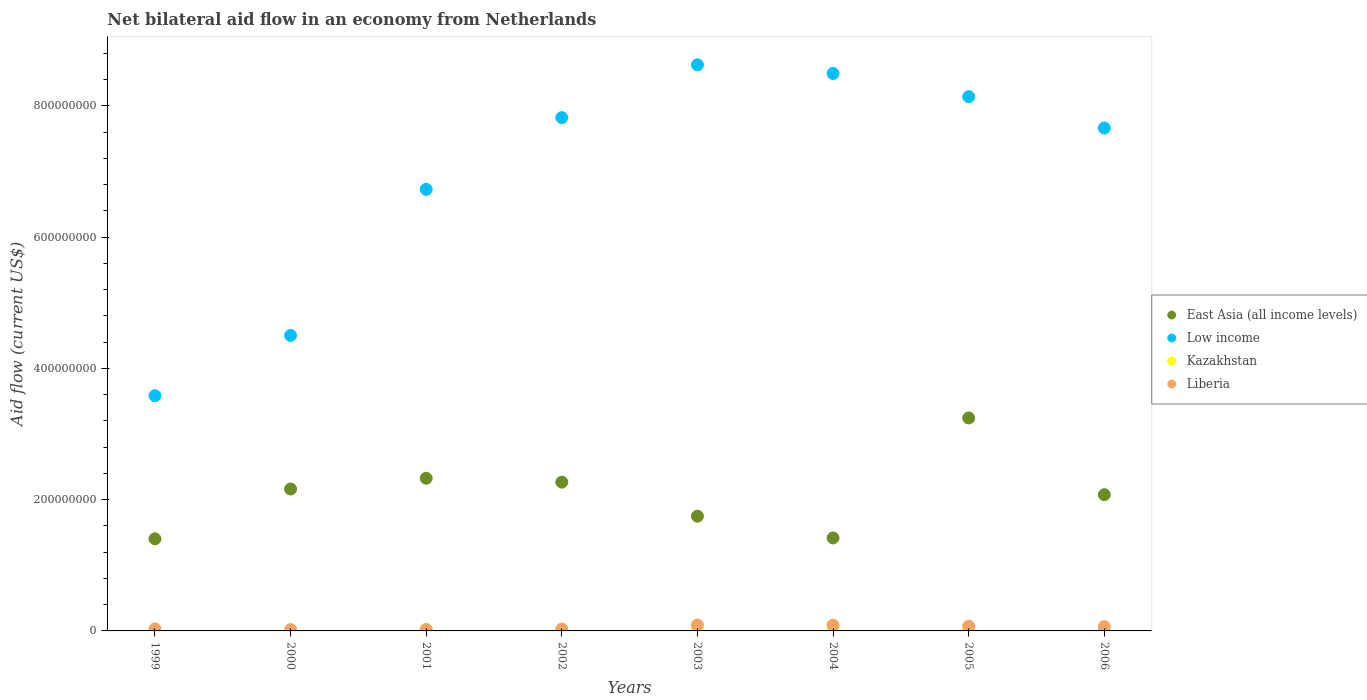How many different coloured dotlines are there?
Your response must be concise. 4. What is the net bilateral aid flow in Liberia in 2002?
Your response must be concise. 2.88e+06. Across all years, what is the maximum net bilateral aid flow in Low income?
Offer a very short reply. 8.63e+08. Across all years, what is the minimum net bilateral aid flow in East Asia (all income levels)?
Provide a succinct answer. 1.40e+08. In which year was the net bilateral aid flow in East Asia (all income levels) maximum?
Give a very brief answer. 2005. In which year was the net bilateral aid flow in East Asia (all income levels) minimum?
Your answer should be compact. 1999. What is the total net bilateral aid flow in Kazakhstan in the graph?
Keep it short and to the point. 1.30e+07. What is the difference between the net bilateral aid flow in East Asia (all income levels) in 1999 and that in 2000?
Give a very brief answer. -7.59e+07. What is the difference between the net bilateral aid flow in East Asia (all income levels) in 1999 and the net bilateral aid flow in Low income in 2001?
Your answer should be very brief. -5.33e+08. What is the average net bilateral aid flow in East Asia (all income levels) per year?
Give a very brief answer. 2.08e+08. In the year 2006, what is the difference between the net bilateral aid flow in Liberia and net bilateral aid flow in East Asia (all income levels)?
Your response must be concise. -2.01e+08. What is the ratio of the net bilateral aid flow in Low income in 1999 to that in 2004?
Keep it short and to the point. 0.42. Is the difference between the net bilateral aid flow in Liberia in 2001 and 2002 greater than the difference between the net bilateral aid flow in East Asia (all income levels) in 2001 and 2002?
Provide a short and direct response. No. What is the difference between the highest and the lowest net bilateral aid flow in Liberia?
Provide a short and direct response. 6.98e+06. In how many years, is the net bilateral aid flow in Low income greater than the average net bilateral aid flow in Low income taken over all years?
Provide a succinct answer. 5. How many dotlines are there?
Make the answer very short. 4. Does the graph contain grids?
Provide a succinct answer. No. Where does the legend appear in the graph?
Keep it short and to the point. Center right. How many legend labels are there?
Your answer should be very brief. 4. What is the title of the graph?
Your answer should be compact. Net bilateral aid flow in an economy from Netherlands. What is the label or title of the X-axis?
Provide a short and direct response. Years. What is the label or title of the Y-axis?
Keep it short and to the point. Aid flow (current US$). What is the Aid flow (current US$) in East Asia (all income levels) in 1999?
Ensure brevity in your answer.  1.40e+08. What is the Aid flow (current US$) of Low income in 1999?
Your answer should be very brief. 3.58e+08. What is the Aid flow (current US$) in Kazakhstan in 1999?
Your response must be concise. 1.20e+05. What is the Aid flow (current US$) of Liberia in 1999?
Make the answer very short. 3.16e+06. What is the Aid flow (current US$) in East Asia (all income levels) in 2000?
Your answer should be compact. 2.16e+08. What is the Aid flow (current US$) in Low income in 2000?
Give a very brief answer. 4.50e+08. What is the Aid flow (current US$) of Kazakhstan in 2000?
Offer a very short reply. 2.90e+05. What is the Aid flow (current US$) in East Asia (all income levels) in 2001?
Offer a terse response. 2.33e+08. What is the Aid flow (current US$) of Low income in 2001?
Offer a very short reply. 6.73e+08. What is the Aid flow (current US$) in Kazakhstan in 2001?
Keep it short and to the point. 2.15e+06. What is the Aid flow (current US$) of Liberia in 2001?
Your answer should be very brief. 2.25e+06. What is the Aid flow (current US$) of East Asia (all income levels) in 2002?
Make the answer very short. 2.27e+08. What is the Aid flow (current US$) in Low income in 2002?
Make the answer very short. 7.82e+08. What is the Aid flow (current US$) of Kazakhstan in 2002?
Make the answer very short. 2.01e+06. What is the Aid flow (current US$) in Liberia in 2002?
Keep it short and to the point. 2.88e+06. What is the Aid flow (current US$) of East Asia (all income levels) in 2003?
Provide a short and direct response. 1.75e+08. What is the Aid flow (current US$) in Low income in 2003?
Offer a terse response. 8.63e+08. What is the Aid flow (current US$) in Kazakhstan in 2003?
Your answer should be very brief. 2.51e+06. What is the Aid flow (current US$) in Liberia in 2003?
Your response must be concise. 8.98e+06. What is the Aid flow (current US$) of East Asia (all income levels) in 2004?
Your answer should be very brief. 1.42e+08. What is the Aid flow (current US$) in Low income in 2004?
Give a very brief answer. 8.49e+08. What is the Aid flow (current US$) of Kazakhstan in 2004?
Your answer should be very brief. 3.32e+06. What is the Aid flow (current US$) in Liberia in 2004?
Keep it short and to the point. 8.62e+06. What is the Aid flow (current US$) in East Asia (all income levels) in 2005?
Offer a terse response. 3.25e+08. What is the Aid flow (current US$) in Low income in 2005?
Offer a very short reply. 8.14e+08. What is the Aid flow (current US$) in Kazakhstan in 2005?
Your answer should be compact. 2.36e+06. What is the Aid flow (current US$) in Liberia in 2005?
Provide a succinct answer. 7.20e+06. What is the Aid flow (current US$) of East Asia (all income levels) in 2006?
Provide a succinct answer. 2.08e+08. What is the Aid flow (current US$) of Low income in 2006?
Keep it short and to the point. 7.66e+08. What is the Aid flow (current US$) of Liberia in 2006?
Your answer should be very brief. 6.53e+06. Across all years, what is the maximum Aid flow (current US$) of East Asia (all income levels)?
Ensure brevity in your answer.  3.25e+08. Across all years, what is the maximum Aid flow (current US$) of Low income?
Your answer should be very brief. 8.63e+08. Across all years, what is the maximum Aid flow (current US$) in Kazakhstan?
Your response must be concise. 3.32e+06. Across all years, what is the maximum Aid flow (current US$) in Liberia?
Make the answer very short. 8.98e+06. Across all years, what is the minimum Aid flow (current US$) of East Asia (all income levels)?
Keep it short and to the point. 1.40e+08. Across all years, what is the minimum Aid flow (current US$) of Low income?
Keep it short and to the point. 3.58e+08. What is the total Aid flow (current US$) of East Asia (all income levels) in the graph?
Your answer should be very brief. 1.66e+09. What is the total Aid flow (current US$) of Low income in the graph?
Provide a succinct answer. 5.56e+09. What is the total Aid flow (current US$) of Kazakhstan in the graph?
Ensure brevity in your answer.  1.30e+07. What is the total Aid flow (current US$) in Liberia in the graph?
Provide a short and direct response. 4.16e+07. What is the difference between the Aid flow (current US$) of East Asia (all income levels) in 1999 and that in 2000?
Your answer should be compact. -7.59e+07. What is the difference between the Aid flow (current US$) of Low income in 1999 and that in 2000?
Offer a very short reply. -9.18e+07. What is the difference between the Aid flow (current US$) in Liberia in 1999 and that in 2000?
Your response must be concise. 1.16e+06. What is the difference between the Aid flow (current US$) in East Asia (all income levels) in 1999 and that in 2001?
Ensure brevity in your answer.  -9.23e+07. What is the difference between the Aid flow (current US$) in Low income in 1999 and that in 2001?
Make the answer very short. -3.14e+08. What is the difference between the Aid flow (current US$) in Kazakhstan in 1999 and that in 2001?
Provide a succinct answer. -2.03e+06. What is the difference between the Aid flow (current US$) in Liberia in 1999 and that in 2001?
Make the answer very short. 9.10e+05. What is the difference between the Aid flow (current US$) in East Asia (all income levels) in 1999 and that in 2002?
Offer a very short reply. -8.64e+07. What is the difference between the Aid flow (current US$) of Low income in 1999 and that in 2002?
Your answer should be compact. -4.24e+08. What is the difference between the Aid flow (current US$) of Kazakhstan in 1999 and that in 2002?
Give a very brief answer. -1.89e+06. What is the difference between the Aid flow (current US$) in Liberia in 1999 and that in 2002?
Keep it short and to the point. 2.80e+05. What is the difference between the Aid flow (current US$) of East Asia (all income levels) in 1999 and that in 2003?
Ensure brevity in your answer.  -3.45e+07. What is the difference between the Aid flow (current US$) of Low income in 1999 and that in 2003?
Your answer should be compact. -5.04e+08. What is the difference between the Aid flow (current US$) in Kazakhstan in 1999 and that in 2003?
Offer a terse response. -2.39e+06. What is the difference between the Aid flow (current US$) of Liberia in 1999 and that in 2003?
Your answer should be very brief. -5.82e+06. What is the difference between the Aid flow (current US$) of East Asia (all income levels) in 1999 and that in 2004?
Make the answer very short. -1.30e+06. What is the difference between the Aid flow (current US$) in Low income in 1999 and that in 2004?
Provide a succinct answer. -4.91e+08. What is the difference between the Aid flow (current US$) in Kazakhstan in 1999 and that in 2004?
Your response must be concise. -3.20e+06. What is the difference between the Aid flow (current US$) of Liberia in 1999 and that in 2004?
Keep it short and to the point. -5.46e+06. What is the difference between the Aid flow (current US$) in East Asia (all income levels) in 1999 and that in 2005?
Your answer should be compact. -1.84e+08. What is the difference between the Aid flow (current US$) of Low income in 1999 and that in 2005?
Provide a succinct answer. -4.56e+08. What is the difference between the Aid flow (current US$) of Kazakhstan in 1999 and that in 2005?
Your answer should be compact. -2.24e+06. What is the difference between the Aid flow (current US$) of Liberia in 1999 and that in 2005?
Provide a succinct answer. -4.04e+06. What is the difference between the Aid flow (current US$) in East Asia (all income levels) in 1999 and that in 2006?
Your response must be concise. -6.72e+07. What is the difference between the Aid flow (current US$) in Low income in 1999 and that in 2006?
Your answer should be very brief. -4.08e+08. What is the difference between the Aid flow (current US$) in Kazakhstan in 1999 and that in 2006?
Give a very brief answer. -1.30e+05. What is the difference between the Aid flow (current US$) of Liberia in 1999 and that in 2006?
Keep it short and to the point. -3.37e+06. What is the difference between the Aid flow (current US$) of East Asia (all income levels) in 2000 and that in 2001?
Keep it short and to the point. -1.64e+07. What is the difference between the Aid flow (current US$) in Low income in 2000 and that in 2001?
Your answer should be compact. -2.23e+08. What is the difference between the Aid flow (current US$) in Kazakhstan in 2000 and that in 2001?
Your response must be concise. -1.86e+06. What is the difference between the Aid flow (current US$) in East Asia (all income levels) in 2000 and that in 2002?
Your answer should be compact. -1.05e+07. What is the difference between the Aid flow (current US$) in Low income in 2000 and that in 2002?
Provide a short and direct response. -3.32e+08. What is the difference between the Aid flow (current US$) of Kazakhstan in 2000 and that in 2002?
Your answer should be compact. -1.72e+06. What is the difference between the Aid flow (current US$) in Liberia in 2000 and that in 2002?
Keep it short and to the point. -8.80e+05. What is the difference between the Aid flow (current US$) in East Asia (all income levels) in 2000 and that in 2003?
Your response must be concise. 4.14e+07. What is the difference between the Aid flow (current US$) in Low income in 2000 and that in 2003?
Keep it short and to the point. -4.12e+08. What is the difference between the Aid flow (current US$) of Kazakhstan in 2000 and that in 2003?
Make the answer very short. -2.22e+06. What is the difference between the Aid flow (current US$) in Liberia in 2000 and that in 2003?
Your answer should be very brief. -6.98e+06. What is the difference between the Aid flow (current US$) in East Asia (all income levels) in 2000 and that in 2004?
Provide a succinct answer. 7.46e+07. What is the difference between the Aid flow (current US$) of Low income in 2000 and that in 2004?
Keep it short and to the point. -3.99e+08. What is the difference between the Aid flow (current US$) in Kazakhstan in 2000 and that in 2004?
Keep it short and to the point. -3.03e+06. What is the difference between the Aid flow (current US$) in Liberia in 2000 and that in 2004?
Your answer should be very brief. -6.62e+06. What is the difference between the Aid flow (current US$) in East Asia (all income levels) in 2000 and that in 2005?
Offer a terse response. -1.08e+08. What is the difference between the Aid flow (current US$) of Low income in 2000 and that in 2005?
Offer a very short reply. -3.64e+08. What is the difference between the Aid flow (current US$) of Kazakhstan in 2000 and that in 2005?
Provide a succinct answer. -2.07e+06. What is the difference between the Aid flow (current US$) in Liberia in 2000 and that in 2005?
Ensure brevity in your answer.  -5.20e+06. What is the difference between the Aid flow (current US$) in East Asia (all income levels) in 2000 and that in 2006?
Offer a very short reply. 8.62e+06. What is the difference between the Aid flow (current US$) of Low income in 2000 and that in 2006?
Your answer should be very brief. -3.16e+08. What is the difference between the Aid flow (current US$) of Kazakhstan in 2000 and that in 2006?
Offer a very short reply. 4.00e+04. What is the difference between the Aid flow (current US$) in Liberia in 2000 and that in 2006?
Provide a short and direct response. -4.53e+06. What is the difference between the Aid flow (current US$) of East Asia (all income levels) in 2001 and that in 2002?
Give a very brief answer. 5.91e+06. What is the difference between the Aid flow (current US$) in Low income in 2001 and that in 2002?
Ensure brevity in your answer.  -1.09e+08. What is the difference between the Aid flow (current US$) in Liberia in 2001 and that in 2002?
Offer a terse response. -6.30e+05. What is the difference between the Aid flow (current US$) in East Asia (all income levels) in 2001 and that in 2003?
Provide a short and direct response. 5.78e+07. What is the difference between the Aid flow (current US$) in Low income in 2001 and that in 2003?
Offer a terse response. -1.90e+08. What is the difference between the Aid flow (current US$) in Kazakhstan in 2001 and that in 2003?
Offer a terse response. -3.60e+05. What is the difference between the Aid flow (current US$) in Liberia in 2001 and that in 2003?
Provide a succinct answer. -6.73e+06. What is the difference between the Aid flow (current US$) in East Asia (all income levels) in 2001 and that in 2004?
Offer a terse response. 9.10e+07. What is the difference between the Aid flow (current US$) in Low income in 2001 and that in 2004?
Ensure brevity in your answer.  -1.77e+08. What is the difference between the Aid flow (current US$) in Kazakhstan in 2001 and that in 2004?
Make the answer very short. -1.17e+06. What is the difference between the Aid flow (current US$) of Liberia in 2001 and that in 2004?
Provide a succinct answer. -6.37e+06. What is the difference between the Aid flow (current US$) in East Asia (all income levels) in 2001 and that in 2005?
Provide a short and direct response. -9.19e+07. What is the difference between the Aid flow (current US$) of Low income in 2001 and that in 2005?
Your answer should be compact. -1.41e+08. What is the difference between the Aid flow (current US$) in Liberia in 2001 and that in 2005?
Give a very brief answer. -4.95e+06. What is the difference between the Aid flow (current US$) of East Asia (all income levels) in 2001 and that in 2006?
Your response must be concise. 2.50e+07. What is the difference between the Aid flow (current US$) of Low income in 2001 and that in 2006?
Your response must be concise. -9.34e+07. What is the difference between the Aid flow (current US$) of Kazakhstan in 2001 and that in 2006?
Ensure brevity in your answer.  1.90e+06. What is the difference between the Aid flow (current US$) of Liberia in 2001 and that in 2006?
Make the answer very short. -4.28e+06. What is the difference between the Aid flow (current US$) in East Asia (all income levels) in 2002 and that in 2003?
Provide a short and direct response. 5.19e+07. What is the difference between the Aid flow (current US$) of Low income in 2002 and that in 2003?
Your answer should be compact. -8.04e+07. What is the difference between the Aid flow (current US$) in Kazakhstan in 2002 and that in 2003?
Your answer should be compact. -5.00e+05. What is the difference between the Aid flow (current US$) of Liberia in 2002 and that in 2003?
Provide a short and direct response. -6.10e+06. What is the difference between the Aid flow (current US$) of East Asia (all income levels) in 2002 and that in 2004?
Give a very brief answer. 8.50e+07. What is the difference between the Aid flow (current US$) of Low income in 2002 and that in 2004?
Your answer should be very brief. -6.73e+07. What is the difference between the Aid flow (current US$) in Kazakhstan in 2002 and that in 2004?
Keep it short and to the point. -1.31e+06. What is the difference between the Aid flow (current US$) of Liberia in 2002 and that in 2004?
Give a very brief answer. -5.74e+06. What is the difference between the Aid flow (current US$) of East Asia (all income levels) in 2002 and that in 2005?
Ensure brevity in your answer.  -9.78e+07. What is the difference between the Aid flow (current US$) of Low income in 2002 and that in 2005?
Your answer should be compact. -3.19e+07. What is the difference between the Aid flow (current US$) of Kazakhstan in 2002 and that in 2005?
Your answer should be compact. -3.50e+05. What is the difference between the Aid flow (current US$) of Liberia in 2002 and that in 2005?
Make the answer very short. -4.32e+06. What is the difference between the Aid flow (current US$) of East Asia (all income levels) in 2002 and that in 2006?
Give a very brief answer. 1.91e+07. What is the difference between the Aid flow (current US$) in Low income in 2002 and that in 2006?
Offer a terse response. 1.58e+07. What is the difference between the Aid flow (current US$) of Kazakhstan in 2002 and that in 2006?
Keep it short and to the point. 1.76e+06. What is the difference between the Aid flow (current US$) in Liberia in 2002 and that in 2006?
Keep it short and to the point. -3.65e+06. What is the difference between the Aid flow (current US$) in East Asia (all income levels) in 2003 and that in 2004?
Your answer should be very brief. 3.32e+07. What is the difference between the Aid flow (current US$) of Low income in 2003 and that in 2004?
Your answer should be very brief. 1.31e+07. What is the difference between the Aid flow (current US$) in Kazakhstan in 2003 and that in 2004?
Your response must be concise. -8.10e+05. What is the difference between the Aid flow (current US$) in Liberia in 2003 and that in 2004?
Keep it short and to the point. 3.60e+05. What is the difference between the Aid flow (current US$) in East Asia (all income levels) in 2003 and that in 2005?
Your answer should be very brief. -1.50e+08. What is the difference between the Aid flow (current US$) in Low income in 2003 and that in 2005?
Provide a succinct answer. 4.84e+07. What is the difference between the Aid flow (current US$) of Liberia in 2003 and that in 2005?
Give a very brief answer. 1.78e+06. What is the difference between the Aid flow (current US$) of East Asia (all income levels) in 2003 and that in 2006?
Your response must be concise. -3.28e+07. What is the difference between the Aid flow (current US$) in Low income in 2003 and that in 2006?
Ensure brevity in your answer.  9.62e+07. What is the difference between the Aid flow (current US$) in Kazakhstan in 2003 and that in 2006?
Your answer should be very brief. 2.26e+06. What is the difference between the Aid flow (current US$) of Liberia in 2003 and that in 2006?
Your response must be concise. 2.45e+06. What is the difference between the Aid flow (current US$) in East Asia (all income levels) in 2004 and that in 2005?
Offer a terse response. -1.83e+08. What is the difference between the Aid flow (current US$) in Low income in 2004 and that in 2005?
Provide a short and direct response. 3.54e+07. What is the difference between the Aid flow (current US$) in Kazakhstan in 2004 and that in 2005?
Your response must be concise. 9.60e+05. What is the difference between the Aid flow (current US$) in Liberia in 2004 and that in 2005?
Your answer should be compact. 1.42e+06. What is the difference between the Aid flow (current US$) in East Asia (all income levels) in 2004 and that in 2006?
Your answer should be compact. -6.60e+07. What is the difference between the Aid flow (current US$) in Low income in 2004 and that in 2006?
Your answer should be very brief. 8.31e+07. What is the difference between the Aid flow (current US$) of Kazakhstan in 2004 and that in 2006?
Offer a very short reply. 3.07e+06. What is the difference between the Aid flow (current US$) in Liberia in 2004 and that in 2006?
Your response must be concise. 2.09e+06. What is the difference between the Aid flow (current US$) in East Asia (all income levels) in 2005 and that in 2006?
Give a very brief answer. 1.17e+08. What is the difference between the Aid flow (current US$) in Low income in 2005 and that in 2006?
Ensure brevity in your answer.  4.78e+07. What is the difference between the Aid flow (current US$) of Kazakhstan in 2005 and that in 2006?
Provide a short and direct response. 2.11e+06. What is the difference between the Aid flow (current US$) of Liberia in 2005 and that in 2006?
Keep it short and to the point. 6.70e+05. What is the difference between the Aid flow (current US$) of East Asia (all income levels) in 1999 and the Aid flow (current US$) of Low income in 2000?
Offer a terse response. -3.10e+08. What is the difference between the Aid flow (current US$) in East Asia (all income levels) in 1999 and the Aid flow (current US$) in Kazakhstan in 2000?
Your answer should be compact. 1.40e+08. What is the difference between the Aid flow (current US$) in East Asia (all income levels) in 1999 and the Aid flow (current US$) in Liberia in 2000?
Provide a succinct answer. 1.38e+08. What is the difference between the Aid flow (current US$) in Low income in 1999 and the Aid flow (current US$) in Kazakhstan in 2000?
Ensure brevity in your answer.  3.58e+08. What is the difference between the Aid flow (current US$) of Low income in 1999 and the Aid flow (current US$) of Liberia in 2000?
Provide a succinct answer. 3.56e+08. What is the difference between the Aid flow (current US$) in Kazakhstan in 1999 and the Aid flow (current US$) in Liberia in 2000?
Offer a very short reply. -1.88e+06. What is the difference between the Aid flow (current US$) of East Asia (all income levels) in 1999 and the Aid flow (current US$) of Low income in 2001?
Keep it short and to the point. -5.33e+08. What is the difference between the Aid flow (current US$) in East Asia (all income levels) in 1999 and the Aid flow (current US$) in Kazakhstan in 2001?
Provide a short and direct response. 1.38e+08. What is the difference between the Aid flow (current US$) of East Asia (all income levels) in 1999 and the Aid flow (current US$) of Liberia in 2001?
Make the answer very short. 1.38e+08. What is the difference between the Aid flow (current US$) of Low income in 1999 and the Aid flow (current US$) of Kazakhstan in 2001?
Offer a very short reply. 3.56e+08. What is the difference between the Aid flow (current US$) in Low income in 1999 and the Aid flow (current US$) in Liberia in 2001?
Offer a terse response. 3.56e+08. What is the difference between the Aid flow (current US$) in Kazakhstan in 1999 and the Aid flow (current US$) in Liberia in 2001?
Provide a short and direct response. -2.13e+06. What is the difference between the Aid flow (current US$) of East Asia (all income levels) in 1999 and the Aid flow (current US$) of Low income in 2002?
Ensure brevity in your answer.  -6.42e+08. What is the difference between the Aid flow (current US$) of East Asia (all income levels) in 1999 and the Aid flow (current US$) of Kazakhstan in 2002?
Give a very brief answer. 1.38e+08. What is the difference between the Aid flow (current US$) in East Asia (all income levels) in 1999 and the Aid flow (current US$) in Liberia in 2002?
Your answer should be very brief. 1.37e+08. What is the difference between the Aid flow (current US$) of Low income in 1999 and the Aid flow (current US$) of Kazakhstan in 2002?
Keep it short and to the point. 3.56e+08. What is the difference between the Aid flow (current US$) of Low income in 1999 and the Aid flow (current US$) of Liberia in 2002?
Offer a very short reply. 3.56e+08. What is the difference between the Aid flow (current US$) of Kazakhstan in 1999 and the Aid flow (current US$) of Liberia in 2002?
Provide a short and direct response. -2.76e+06. What is the difference between the Aid flow (current US$) of East Asia (all income levels) in 1999 and the Aid flow (current US$) of Low income in 2003?
Offer a terse response. -7.22e+08. What is the difference between the Aid flow (current US$) in East Asia (all income levels) in 1999 and the Aid flow (current US$) in Kazakhstan in 2003?
Provide a short and direct response. 1.38e+08. What is the difference between the Aid flow (current US$) of East Asia (all income levels) in 1999 and the Aid flow (current US$) of Liberia in 2003?
Your answer should be very brief. 1.31e+08. What is the difference between the Aid flow (current US$) of Low income in 1999 and the Aid flow (current US$) of Kazakhstan in 2003?
Offer a terse response. 3.56e+08. What is the difference between the Aid flow (current US$) of Low income in 1999 and the Aid flow (current US$) of Liberia in 2003?
Provide a succinct answer. 3.49e+08. What is the difference between the Aid flow (current US$) in Kazakhstan in 1999 and the Aid flow (current US$) in Liberia in 2003?
Your answer should be compact. -8.86e+06. What is the difference between the Aid flow (current US$) of East Asia (all income levels) in 1999 and the Aid flow (current US$) of Low income in 2004?
Provide a succinct answer. -7.09e+08. What is the difference between the Aid flow (current US$) in East Asia (all income levels) in 1999 and the Aid flow (current US$) in Kazakhstan in 2004?
Offer a terse response. 1.37e+08. What is the difference between the Aid flow (current US$) in East Asia (all income levels) in 1999 and the Aid flow (current US$) in Liberia in 2004?
Your answer should be compact. 1.32e+08. What is the difference between the Aid flow (current US$) in Low income in 1999 and the Aid flow (current US$) in Kazakhstan in 2004?
Your response must be concise. 3.55e+08. What is the difference between the Aid flow (current US$) in Low income in 1999 and the Aid flow (current US$) in Liberia in 2004?
Your response must be concise. 3.50e+08. What is the difference between the Aid flow (current US$) in Kazakhstan in 1999 and the Aid flow (current US$) in Liberia in 2004?
Provide a short and direct response. -8.50e+06. What is the difference between the Aid flow (current US$) in East Asia (all income levels) in 1999 and the Aid flow (current US$) in Low income in 2005?
Your answer should be very brief. -6.74e+08. What is the difference between the Aid flow (current US$) in East Asia (all income levels) in 1999 and the Aid flow (current US$) in Kazakhstan in 2005?
Offer a very short reply. 1.38e+08. What is the difference between the Aid flow (current US$) of East Asia (all income levels) in 1999 and the Aid flow (current US$) of Liberia in 2005?
Keep it short and to the point. 1.33e+08. What is the difference between the Aid flow (current US$) in Low income in 1999 and the Aid flow (current US$) in Kazakhstan in 2005?
Give a very brief answer. 3.56e+08. What is the difference between the Aid flow (current US$) in Low income in 1999 and the Aid flow (current US$) in Liberia in 2005?
Ensure brevity in your answer.  3.51e+08. What is the difference between the Aid flow (current US$) of Kazakhstan in 1999 and the Aid flow (current US$) of Liberia in 2005?
Make the answer very short. -7.08e+06. What is the difference between the Aid flow (current US$) in East Asia (all income levels) in 1999 and the Aid flow (current US$) in Low income in 2006?
Provide a succinct answer. -6.26e+08. What is the difference between the Aid flow (current US$) of East Asia (all income levels) in 1999 and the Aid flow (current US$) of Kazakhstan in 2006?
Your response must be concise. 1.40e+08. What is the difference between the Aid flow (current US$) of East Asia (all income levels) in 1999 and the Aid flow (current US$) of Liberia in 2006?
Ensure brevity in your answer.  1.34e+08. What is the difference between the Aid flow (current US$) of Low income in 1999 and the Aid flow (current US$) of Kazakhstan in 2006?
Provide a succinct answer. 3.58e+08. What is the difference between the Aid flow (current US$) of Low income in 1999 and the Aid flow (current US$) of Liberia in 2006?
Keep it short and to the point. 3.52e+08. What is the difference between the Aid flow (current US$) in Kazakhstan in 1999 and the Aid flow (current US$) in Liberia in 2006?
Your response must be concise. -6.41e+06. What is the difference between the Aid flow (current US$) of East Asia (all income levels) in 2000 and the Aid flow (current US$) of Low income in 2001?
Offer a terse response. -4.57e+08. What is the difference between the Aid flow (current US$) in East Asia (all income levels) in 2000 and the Aid flow (current US$) in Kazakhstan in 2001?
Offer a terse response. 2.14e+08. What is the difference between the Aid flow (current US$) in East Asia (all income levels) in 2000 and the Aid flow (current US$) in Liberia in 2001?
Your answer should be very brief. 2.14e+08. What is the difference between the Aid flow (current US$) in Low income in 2000 and the Aid flow (current US$) in Kazakhstan in 2001?
Provide a succinct answer. 4.48e+08. What is the difference between the Aid flow (current US$) of Low income in 2000 and the Aid flow (current US$) of Liberia in 2001?
Make the answer very short. 4.48e+08. What is the difference between the Aid flow (current US$) of Kazakhstan in 2000 and the Aid flow (current US$) of Liberia in 2001?
Keep it short and to the point. -1.96e+06. What is the difference between the Aid flow (current US$) in East Asia (all income levels) in 2000 and the Aid flow (current US$) in Low income in 2002?
Give a very brief answer. -5.66e+08. What is the difference between the Aid flow (current US$) of East Asia (all income levels) in 2000 and the Aid flow (current US$) of Kazakhstan in 2002?
Offer a terse response. 2.14e+08. What is the difference between the Aid flow (current US$) in East Asia (all income levels) in 2000 and the Aid flow (current US$) in Liberia in 2002?
Ensure brevity in your answer.  2.13e+08. What is the difference between the Aid flow (current US$) in Low income in 2000 and the Aid flow (current US$) in Kazakhstan in 2002?
Ensure brevity in your answer.  4.48e+08. What is the difference between the Aid flow (current US$) of Low income in 2000 and the Aid flow (current US$) of Liberia in 2002?
Provide a succinct answer. 4.47e+08. What is the difference between the Aid flow (current US$) in Kazakhstan in 2000 and the Aid flow (current US$) in Liberia in 2002?
Keep it short and to the point. -2.59e+06. What is the difference between the Aid flow (current US$) of East Asia (all income levels) in 2000 and the Aid flow (current US$) of Low income in 2003?
Your response must be concise. -6.46e+08. What is the difference between the Aid flow (current US$) of East Asia (all income levels) in 2000 and the Aid flow (current US$) of Kazakhstan in 2003?
Provide a succinct answer. 2.14e+08. What is the difference between the Aid flow (current US$) of East Asia (all income levels) in 2000 and the Aid flow (current US$) of Liberia in 2003?
Give a very brief answer. 2.07e+08. What is the difference between the Aid flow (current US$) in Low income in 2000 and the Aid flow (current US$) in Kazakhstan in 2003?
Offer a terse response. 4.48e+08. What is the difference between the Aid flow (current US$) in Low income in 2000 and the Aid flow (current US$) in Liberia in 2003?
Make the answer very short. 4.41e+08. What is the difference between the Aid flow (current US$) in Kazakhstan in 2000 and the Aid flow (current US$) in Liberia in 2003?
Provide a succinct answer. -8.69e+06. What is the difference between the Aid flow (current US$) of East Asia (all income levels) in 2000 and the Aid flow (current US$) of Low income in 2004?
Provide a short and direct response. -6.33e+08. What is the difference between the Aid flow (current US$) in East Asia (all income levels) in 2000 and the Aid flow (current US$) in Kazakhstan in 2004?
Your response must be concise. 2.13e+08. What is the difference between the Aid flow (current US$) of East Asia (all income levels) in 2000 and the Aid flow (current US$) of Liberia in 2004?
Your answer should be compact. 2.08e+08. What is the difference between the Aid flow (current US$) of Low income in 2000 and the Aid flow (current US$) of Kazakhstan in 2004?
Make the answer very short. 4.47e+08. What is the difference between the Aid flow (current US$) in Low income in 2000 and the Aid flow (current US$) in Liberia in 2004?
Make the answer very short. 4.42e+08. What is the difference between the Aid flow (current US$) of Kazakhstan in 2000 and the Aid flow (current US$) of Liberia in 2004?
Provide a succinct answer. -8.33e+06. What is the difference between the Aid flow (current US$) of East Asia (all income levels) in 2000 and the Aid flow (current US$) of Low income in 2005?
Offer a terse response. -5.98e+08. What is the difference between the Aid flow (current US$) in East Asia (all income levels) in 2000 and the Aid flow (current US$) in Kazakhstan in 2005?
Your answer should be compact. 2.14e+08. What is the difference between the Aid flow (current US$) of East Asia (all income levels) in 2000 and the Aid flow (current US$) of Liberia in 2005?
Offer a very short reply. 2.09e+08. What is the difference between the Aid flow (current US$) in Low income in 2000 and the Aid flow (current US$) in Kazakhstan in 2005?
Your answer should be compact. 4.48e+08. What is the difference between the Aid flow (current US$) of Low income in 2000 and the Aid flow (current US$) of Liberia in 2005?
Offer a very short reply. 4.43e+08. What is the difference between the Aid flow (current US$) in Kazakhstan in 2000 and the Aid flow (current US$) in Liberia in 2005?
Make the answer very short. -6.91e+06. What is the difference between the Aid flow (current US$) of East Asia (all income levels) in 2000 and the Aid flow (current US$) of Low income in 2006?
Make the answer very short. -5.50e+08. What is the difference between the Aid flow (current US$) of East Asia (all income levels) in 2000 and the Aid flow (current US$) of Kazakhstan in 2006?
Offer a very short reply. 2.16e+08. What is the difference between the Aid flow (current US$) of East Asia (all income levels) in 2000 and the Aid flow (current US$) of Liberia in 2006?
Ensure brevity in your answer.  2.10e+08. What is the difference between the Aid flow (current US$) of Low income in 2000 and the Aid flow (current US$) of Kazakhstan in 2006?
Make the answer very short. 4.50e+08. What is the difference between the Aid flow (current US$) of Low income in 2000 and the Aid flow (current US$) of Liberia in 2006?
Keep it short and to the point. 4.44e+08. What is the difference between the Aid flow (current US$) of Kazakhstan in 2000 and the Aid flow (current US$) of Liberia in 2006?
Provide a short and direct response. -6.24e+06. What is the difference between the Aid flow (current US$) in East Asia (all income levels) in 2001 and the Aid flow (current US$) in Low income in 2002?
Give a very brief answer. -5.50e+08. What is the difference between the Aid flow (current US$) in East Asia (all income levels) in 2001 and the Aid flow (current US$) in Kazakhstan in 2002?
Keep it short and to the point. 2.31e+08. What is the difference between the Aid flow (current US$) of East Asia (all income levels) in 2001 and the Aid flow (current US$) of Liberia in 2002?
Give a very brief answer. 2.30e+08. What is the difference between the Aid flow (current US$) in Low income in 2001 and the Aid flow (current US$) in Kazakhstan in 2002?
Keep it short and to the point. 6.71e+08. What is the difference between the Aid flow (current US$) of Low income in 2001 and the Aid flow (current US$) of Liberia in 2002?
Make the answer very short. 6.70e+08. What is the difference between the Aid flow (current US$) in Kazakhstan in 2001 and the Aid flow (current US$) in Liberia in 2002?
Offer a terse response. -7.30e+05. What is the difference between the Aid flow (current US$) of East Asia (all income levels) in 2001 and the Aid flow (current US$) of Low income in 2003?
Give a very brief answer. -6.30e+08. What is the difference between the Aid flow (current US$) in East Asia (all income levels) in 2001 and the Aid flow (current US$) in Kazakhstan in 2003?
Offer a terse response. 2.30e+08. What is the difference between the Aid flow (current US$) of East Asia (all income levels) in 2001 and the Aid flow (current US$) of Liberia in 2003?
Offer a very short reply. 2.24e+08. What is the difference between the Aid flow (current US$) of Low income in 2001 and the Aid flow (current US$) of Kazakhstan in 2003?
Your response must be concise. 6.70e+08. What is the difference between the Aid flow (current US$) of Low income in 2001 and the Aid flow (current US$) of Liberia in 2003?
Offer a terse response. 6.64e+08. What is the difference between the Aid flow (current US$) of Kazakhstan in 2001 and the Aid flow (current US$) of Liberia in 2003?
Offer a very short reply. -6.83e+06. What is the difference between the Aid flow (current US$) in East Asia (all income levels) in 2001 and the Aid flow (current US$) in Low income in 2004?
Ensure brevity in your answer.  -6.17e+08. What is the difference between the Aid flow (current US$) of East Asia (all income levels) in 2001 and the Aid flow (current US$) of Kazakhstan in 2004?
Your answer should be compact. 2.29e+08. What is the difference between the Aid flow (current US$) in East Asia (all income levels) in 2001 and the Aid flow (current US$) in Liberia in 2004?
Offer a very short reply. 2.24e+08. What is the difference between the Aid flow (current US$) in Low income in 2001 and the Aid flow (current US$) in Kazakhstan in 2004?
Your answer should be compact. 6.70e+08. What is the difference between the Aid flow (current US$) in Low income in 2001 and the Aid flow (current US$) in Liberia in 2004?
Offer a terse response. 6.64e+08. What is the difference between the Aid flow (current US$) in Kazakhstan in 2001 and the Aid flow (current US$) in Liberia in 2004?
Give a very brief answer. -6.47e+06. What is the difference between the Aid flow (current US$) of East Asia (all income levels) in 2001 and the Aid flow (current US$) of Low income in 2005?
Provide a short and direct response. -5.81e+08. What is the difference between the Aid flow (current US$) of East Asia (all income levels) in 2001 and the Aid flow (current US$) of Kazakhstan in 2005?
Your answer should be very brief. 2.30e+08. What is the difference between the Aid flow (current US$) in East Asia (all income levels) in 2001 and the Aid flow (current US$) in Liberia in 2005?
Give a very brief answer. 2.25e+08. What is the difference between the Aid flow (current US$) of Low income in 2001 and the Aid flow (current US$) of Kazakhstan in 2005?
Provide a succinct answer. 6.71e+08. What is the difference between the Aid flow (current US$) of Low income in 2001 and the Aid flow (current US$) of Liberia in 2005?
Offer a terse response. 6.66e+08. What is the difference between the Aid flow (current US$) in Kazakhstan in 2001 and the Aid flow (current US$) in Liberia in 2005?
Your answer should be compact. -5.05e+06. What is the difference between the Aid flow (current US$) in East Asia (all income levels) in 2001 and the Aid flow (current US$) in Low income in 2006?
Your answer should be compact. -5.34e+08. What is the difference between the Aid flow (current US$) of East Asia (all income levels) in 2001 and the Aid flow (current US$) of Kazakhstan in 2006?
Offer a very short reply. 2.32e+08. What is the difference between the Aid flow (current US$) of East Asia (all income levels) in 2001 and the Aid flow (current US$) of Liberia in 2006?
Give a very brief answer. 2.26e+08. What is the difference between the Aid flow (current US$) of Low income in 2001 and the Aid flow (current US$) of Kazakhstan in 2006?
Your answer should be compact. 6.73e+08. What is the difference between the Aid flow (current US$) in Low income in 2001 and the Aid flow (current US$) in Liberia in 2006?
Offer a very short reply. 6.66e+08. What is the difference between the Aid flow (current US$) in Kazakhstan in 2001 and the Aid flow (current US$) in Liberia in 2006?
Ensure brevity in your answer.  -4.38e+06. What is the difference between the Aid flow (current US$) of East Asia (all income levels) in 2002 and the Aid flow (current US$) of Low income in 2003?
Make the answer very short. -6.36e+08. What is the difference between the Aid flow (current US$) of East Asia (all income levels) in 2002 and the Aid flow (current US$) of Kazakhstan in 2003?
Offer a terse response. 2.24e+08. What is the difference between the Aid flow (current US$) in East Asia (all income levels) in 2002 and the Aid flow (current US$) in Liberia in 2003?
Give a very brief answer. 2.18e+08. What is the difference between the Aid flow (current US$) of Low income in 2002 and the Aid flow (current US$) of Kazakhstan in 2003?
Give a very brief answer. 7.80e+08. What is the difference between the Aid flow (current US$) in Low income in 2002 and the Aid flow (current US$) in Liberia in 2003?
Offer a very short reply. 7.73e+08. What is the difference between the Aid flow (current US$) in Kazakhstan in 2002 and the Aid flow (current US$) in Liberia in 2003?
Give a very brief answer. -6.97e+06. What is the difference between the Aid flow (current US$) in East Asia (all income levels) in 2002 and the Aid flow (current US$) in Low income in 2004?
Your answer should be very brief. -6.23e+08. What is the difference between the Aid flow (current US$) of East Asia (all income levels) in 2002 and the Aid flow (current US$) of Kazakhstan in 2004?
Keep it short and to the point. 2.23e+08. What is the difference between the Aid flow (current US$) of East Asia (all income levels) in 2002 and the Aid flow (current US$) of Liberia in 2004?
Ensure brevity in your answer.  2.18e+08. What is the difference between the Aid flow (current US$) of Low income in 2002 and the Aid flow (current US$) of Kazakhstan in 2004?
Provide a short and direct response. 7.79e+08. What is the difference between the Aid flow (current US$) in Low income in 2002 and the Aid flow (current US$) in Liberia in 2004?
Give a very brief answer. 7.74e+08. What is the difference between the Aid flow (current US$) in Kazakhstan in 2002 and the Aid flow (current US$) in Liberia in 2004?
Keep it short and to the point. -6.61e+06. What is the difference between the Aid flow (current US$) of East Asia (all income levels) in 2002 and the Aid flow (current US$) of Low income in 2005?
Give a very brief answer. -5.87e+08. What is the difference between the Aid flow (current US$) of East Asia (all income levels) in 2002 and the Aid flow (current US$) of Kazakhstan in 2005?
Offer a very short reply. 2.24e+08. What is the difference between the Aid flow (current US$) of East Asia (all income levels) in 2002 and the Aid flow (current US$) of Liberia in 2005?
Your response must be concise. 2.20e+08. What is the difference between the Aid flow (current US$) of Low income in 2002 and the Aid flow (current US$) of Kazakhstan in 2005?
Your answer should be very brief. 7.80e+08. What is the difference between the Aid flow (current US$) in Low income in 2002 and the Aid flow (current US$) in Liberia in 2005?
Make the answer very short. 7.75e+08. What is the difference between the Aid flow (current US$) of Kazakhstan in 2002 and the Aid flow (current US$) of Liberia in 2005?
Provide a short and direct response. -5.19e+06. What is the difference between the Aid flow (current US$) in East Asia (all income levels) in 2002 and the Aid flow (current US$) in Low income in 2006?
Keep it short and to the point. -5.40e+08. What is the difference between the Aid flow (current US$) of East Asia (all income levels) in 2002 and the Aid flow (current US$) of Kazakhstan in 2006?
Keep it short and to the point. 2.26e+08. What is the difference between the Aid flow (current US$) in East Asia (all income levels) in 2002 and the Aid flow (current US$) in Liberia in 2006?
Offer a terse response. 2.20e+08. What is the difference between the Aid flow (current US$) in Low income in 2002 and the Aid flow (current US$) in Kazakhstan in 2006?
Provide a succinct answer. 7.82e+08. What is the difference between the Aid flow (current US$) of Low income in 2002 and the Aid flow (current US$) of Liberia in 2006?
Keep it short and to the point. 7.76e+08. What is the difference between the Aid flow (current US$) in Kazakhstan in 2002 and the Aid flow (current US$) in Liberia in 2006?
Keep it short and to the point. -4.52e+06. What is the difference between the Aid flow (current US$) of East Asia (all income levels) in 2003 and the Aid flow (current US$) of Low income in 2004?
Ensure brevity in your answer.  -6.75e+08. What is the difference between the Aid flow (current US$) in East Asia (all income levels) in 2003 and the Aid flow (current US$) in Kazakhstan in 2004?
Provide a succinct answer. 1.72e+08. What is the difference between the Aid flow (current US$) in East Asia (all income levels) in 2003 and the Aid flow (current US$) in Liberia in 2004?
Keep it short and to the point. 1.66e+08. What is the difference between the Aid flow (current US$) of Low income in 2003 and the Aid flow (current US$) of Kazakhstan in 2004?
Ensure brevity in your answer.  8.59e+08. What is the difference between the Aid flow (current US$) of Low income in 2003 and the Aid flow (current US$) of Liberia in 2004?
Offer a terse response. 8.54e+08. What is the difference between the Aid flow (current US$) in Kazakhstan in 2003 and the Aid flow (current US$) in Liberia in 2004?
Your response must be concise. -6.11e+06. What is the difference between the Aid flow (current US$) in East Asia (all income levels) in 2003 and the Aid flow (current US$) in Low income in 2005?
Give a very brief answer. -6.39e+08. What is the difference between the Aid flow (current US$) in East Asia (all income levels) in 2003 and the Aid flow (current US$) in Kazakhstan in 2005?
Ensure brevity in your answer.  1.72e+08. What is the difference between the Aid flow (current US$) of East Asia (all income levels) in 2003 and the Aid flow (current US$) of Liberia in 2005?
Provide a short and direct response. 1.68e+08. What is the difference between the Aid flow (current US$) of Low income in 2003 and the Aid flow (current US$) of Kazakhstan in 2005?
Offer a terse response. 8.60e+08. What is the difference between the Aid flow (current US$) in Low income in 2003 and the Aid flow (current US$) in Liberia in 2005?
Keep it short and to the point. 8.55e+08. What is the difference between the Aid flow (current US$) in Kazakhstan in 2003 and the Aid flow (current US$) in Liberia in 2005?
Your response must be concise. -4.69e+06. What is the difference between the Aid flow (current US$) of East Asia (all income levels) in 2003 and the Aid flow (current US$) of Low income in 2006?
Give a very brief answer. -5.92e+08. What is the difference between the Aid flow (current US$) in East Asia (all income levels) in 2003 and the Aid flow (current US$) in Kazakhstan in 2006?
Make the answer very short. 1.75e+08. What is the difference between the Aid flow (current US$) in East Asia (all income levels) in 2003 and the Aid flow (current US$) in Liberia in 2006?
Offer a terse response. 1.68e+08. What is the difference between the Aid flow (current US$) of Low income in 2003 and the Aid flow (current US$) of Kazakhstan in 2006?
Offer a very short reply. 8.62e+08. What is the difference between the Aid flow (current US$) of Low income in 2003 and the Aid flow (current US$) of Liberia in 2006?
Ensure brevity in your answer.  8.56e+08. What is the difference between the Aid flow (current US$) in Kazakhstan in 2003 and the Aid flow (current US$) in Liberia in 2006?
Your response must be concise. -4.02e+06. What is the difference between the Aid flow (current US$) of East Asia (all income levels) in 2004 and the Aid flow (current US$) of Low income in 2005?
Your answer should be very brief. -6.72e+08. What is the difference between the Aid flow (current US$) of East Asia (all income levels) in 2004 and the Aid flow (current US$) of Kazakhstan in 2005?
Your response must be concise. 1.39e+08. What is the difference between the Aid flow (current US$) of East Asia (all income levels) in 2004 and the Aid flow (current US$) of Liberia in 2005?
Provide a short and direct response. 1.34e+08. What is the difference between the Aid flow (current US$) of Low income in 2004 and the Aid flow (current US$) of Kazakhstan in 2005?
Make the answer very short. 8.47e+08. What is the difference between the Aid flow (current US$) of Low income in 2004 and the Aid flow (current US$) of Liberia in 2005?
Make the answer very short. 8.42e+08. What is the difference between the Aid flow (current US$) in Kazakhstan in 2004 and the Aid flow (current US$) in Liberia in 2005?
Make the answer very short. -3.88e+06. What is the difference between the Aid flow (current US$) in East Asia (all income levels) in 2004 and the Aid flow (current US$) in Low income in 2006?
Your answer should be very brief. -6.25e+08. What is the difference between the Aid flow (current US$) of East Asia (all income levels) in 2004 and the Aid flow (current US$) of Kazakhstan in 2006?
Offer a terse response. 1.41e+08. What is the difference between the Aid flow (current US$) of East Asia (all income levels) in 2004 and the Aid flow (current US$) of Liberia in 2006?
Make the answer very short. 1.35e+08. What is the difference between the Aid flow (current US$) in Low income in 2004 and the Aid flow (current US$) in Kazakhstan in 2006?
Keep it short and to the point. 8.49e+08. What is the difference between the Aid flow (current US$) in Low income in 2004 and the Aid flow (current US$) in Liberia in 2006?
Keep it short and to the point. 8.43e+08. What is the difference between the Aid flow (current US$) in Kazakhstan in 2004 and the Aid flow (current US$) in Liberia in 2006?
Make the answer very short. -3.21e+06. What is the difference between the Aid flow (current US$) in East Asia (all income levels) in 2005 and the Aid flow (current US$) in Low income in 2006?
Your answer should be very brief. -4.42e+08. What is the difference between the Aid flow (current US$) of East Asia (all income levels) in 2005 and the Aid flow (current US$) of Kazakhstan in 2006?
Keep it short and to the point. 3.24e+08. What is the difference between the Aid flow (current US$) in East Asia (all income levels) in 2005 and the Aid flow (current US$) in Liberia in 2006?
Give a very brief answer. 3.18e+08. What is the difference between the Aid flow (current US$) of Low income in 2005 and the Aid flow (current US$) of Kazakhstan in 2006?
Ensure brevity in your answer.  8.14e+08. What is the difference between the Aid flow (current US$) in Low income in 2005 and the Aid flow (current US$) in Liberia in 2006?
Make the answer very short. 8.08e+08. What is the difference between the Aid flow (current US$) in Kazakhstan in 2005 and the Aid flow (current US$) in Liberia in 2006?
Offer a very short reply. -4.17e+06. What is the average Aid flow (current US$) of East Asia (all income levels) per year?
Keep it short and to the point. 2.08e+08. What is the average Aid flow (current US$) in Low income per year?
Provide a short and direct response. 6.95e+08. What is the average Aid flow (current US$) of Kazakhstan per year?
Provide a short and direct response. 1.63e+06. What is the average Aid flow (current US$) in Liberia per year?
Offer a terse response. 5.20e+06. In the year 1999, what is the difference between the Aid flow (current US$) of East Asia (all income levels) and Aid flow (current US$) of Low income?
Offer a terse response. -2.18e+08. In the year 1999, what is the difference between the Aid flow (current US$) in East Asia (all income levels) and Aid flow (current US$) in Kazakhstan?
Keep it short and to the point. 1.40e+08. In the year 1999, what is the difference between the Aid flow (current US$) of East Asia (all income levels) and Aid flow (current US$) of Liberia?
Your answer should be very brief. 1.37e+08. In the year 1999, what is the difference between the Aid flow (current US$) of Low income and Aid flow (current US$) of Kazakhstan?
Give a very brief answer. 3.58e+08. In the year 1999, what is the difference between the Aid flow (current US$) in Low income and Aid flow (current US$) in Liberia?
Offer a terse response. 3.55e+08. In the year 1999, what is the difference between the Aid flow (current US$) in Kazakhstan and Aid flow (current US$) in Liberia?
Provide a short and direct response. -3.04e+06. In the year 2000, what is the difference between the Aid flow (current US$) of East Asia (all income levels) and Aid flow (current US$) of Low income?
Your response must be concise. -2.34e+08. In the year 2000, what is the difference between the Aid flow (current US$) of East Asia (all income levels) and Aid flow (current US$) of Kazakhstan?
Offer a very short reply. 2.16e+08. In the year 2000, what is the difference between the Aid flow (current US$) of East Asia (all income levels) and Aid flow (current US$) of Liberia?
Offer a very short reply. 2.14e+08. In the year 2000, what is the difference between the Aid flow (current US$) in Low income and Aid flow (current US$) in Kazakhstan?
Make the answer very short. 4.50e+08. In the year 2000, what is the difference between the Aid flow (current US$) of Low income and Aid flow (current US$) of Liberia?
Offer a very short reply. 4.48e+08. In the year 2000, what is the difference between the Aid flow (current US$) of Kazakhstan and Aid flow (current US$) of Liberia?
Offer a terse response. -1.71e+06. In the year 2001, what is the difference between the Aid flow (current US$) in East Asia (all income levels) and Aid flow (current US$) in Low income?
Ensure brevity in your answer.  -4.40e+08. In the year 2001, what is the difference between the Aid flow (current US$) in East Asia (all income levels) and Aid flow (current US$) in Kazakhstan?
Give a very brief answer. 2.30e+08. In the year 2001, what is the difference between the Aid flow (current US$) of East Asia (all income levels) and Aid flow (current US$) of Liberia?
Offer a very short reply. 2.30e+08. In the year 2001, what is the difference between the Aid flow (current US$) of Low income and Aid flow (current US$) of Kazakhstan?
Offer a terse response. 6.71e+08. In the year 2001, what is the difference between the Aid flow (current US$) of Low income and Aid flow (current US$) of Liberia?
Offer a terse response. 6.71e+08. In the year 2002, what is the difference between the Aid flow (current US$) of East Asia (all income levels) and Aid flow (current US$) of Low income?
Provide a succinct answer. -5.55e+08. In the year 2002, what is the difference between the Aid flow (current US$) of East Asia (all income levels) and Aid flow (current US$) of Kazakhstan?
Your response must be concise. 2.25e+08. In the year 2002, what is the difference between the Aid flow (current US$) of East Asia (all income levels) and Aid flow (current US$) of Liberia?
Give a very brief answer. 2.24e+08. In the year 2002, what is the difference between the Aid flow (current US$) of Low income and Aid flow (current US$) of Kazakhstan?
Ensure brevity in your answer.  7.80e+08. In the year 2002, what is the difference between the Aid flow (current US$) in Low income and Aid flow (current US$) in Liberia?
Provide a short and direct response. 7.79e+08. In the year 2002, what is the difference between the Aid flow (current US$) of Kazakhstan and Aid flow (current US$) of Liberia?
Offer a very short reply. -8.70e+05. In the year 2003, what is the difference between the Aid flow (current US$) of East Asia (all income levels) and Aid flow (current US$) of Low income?
Your response must be concise. -6.88e+08. In the year 2003, what is the difference between the Aid flow (current US$) of East Asia (all income levels) and Aid flow (current US$) of Kazakhstan?
Provide a succinct answer. 1.72e+08. In the year 2003, what is the difference between the Aid flow (current US$) of East Asia (all income levels) and Aid flow (current US$) of Liberia?
Ensure brevity in your answer.  1.66e+08. In the year 2003, what is the difference between the Aid flow (current US$) in Low income and Aid flow (current US$) in Kazakhstan?
Provide a succinct answer. 8.60e+08. In the year 2003, what is the difference between the Aid flow (current US$) in Low income and Aid flow (current US$) in Liberia?
Ensure brevity in your answer.  8.54e+08. In the year 2003, what is the difference between the Aid flow (current US$) in Kazakhstan and Aid flow (current US$) in Liberia?
Keep it short and to the point. -6.47e+06. In the year 2004, what is the difference between the Aid flow (current US$) of East Asia (all income levels) and Aid flow (current US$) of Low income?
Keep it short and to the point. -7.08e+08. In the year 2004, what is the difference between the Aid flow (current US$) of East Asia (all income levels) and Aid flow (current US$) of Kazakhstan?
Your response must be concise. 1.38e+08. In the year 2004, what is the difference between the Aid flow (current US$) in East Asia (all income levels) and Aid flow (current US$) in Liberia?
Give a very brief answer. 1.33e+08. In the year 2004, what is the difference between the Aid flow (current US$) of Low income and Aid flow (current US$) of Kazakhstan?
Give a very brief answer. 8.46e+08. In the year 2004, what is the difference between the Aid flow (current US$) in Low income and Aid flow (current US$) in Liberia?
Offer a terse response. 8.41e+08. In the year 2004, what is the difference between the Aid flow (current US$) in Kazakhstan and Aid flow (current US$) in Liberia?
Offer a terse response. -5.30e+06. In the year 2005, what is the difference between the Aid flow (current US$) in East Asia (all income levels) and Aid flow (current US$) in Low income?
Your answer should be compact. -4.90e+08. In the year 2005, what is the difference between the Aid flow (current US$) of East Asia (all income levels) and Aid flow (current US$) of Kazakhstan?
Offer a very short reply. 3.22e+08. In the year 2005, what is the difference between the Aid flow (current US$) in East Asia (all income levels) and Aid flow (current US$) in Liberia?
Offer a very short reply. 3.17e+08. In the year 2005, what is the difference between the Aid flow (current US$) in Low income and Aid flow (current US$) in Kazakhstan?
Make the answer very short. 8.12e+08. In the year 2005, what is the difference between the Aid flow (current US$) in Low income and Aid flow (current US$) in Liberia?
Ensure brevity in your answer.  8.07e+08. In the year 2005, what is the difference between the Aid flow (current US$) in Kazakhstan and Aid flow (current US$) in Liberia?
Offer a very short reply. -4.84e+06. In the year 2006, what is the difference between the Aid flow (current US$) of East Asia (all income levels) and Aid flow (current US$) of Low income?
Offer a terse response. -5.59e+08. In the year 2006, what is the difference between the Aid flow (current US$) of East Asia (all income levels) and Aid flow (current US$) of Kazakhstan?
Give a very brief answer. 2.07e+08. In the year 2006, what is the difference between the Aid flow (current US$) in East Asia (all income levels) and Aid flow (current US$) in Liberia?
Give a very brief answer. 2.01e+08. In the year 2006, what is the difference between the Aid flow (current US$) of Low income and Aid flow (current US$) of Kazakhstan?
Your answer should be compact. 7.66e+08. In the year 2006, what is the difference between the Aid flow (current US$) of Low income and Aid flow (current US$) of Liberia?
Provide a short and direct response. 7.60e+08. In the year 2006, what is the difference between the Aid flow (current US$) in Kazakhstan and Aid flow (current US$) in Liberia?
Offer a very short reply. -6.28e+06. What is the ratio of the Aid flow (current US$) of East Asia (all income levels) in 1999 to that in 2000?
Make the answer very short. 0.65. What is the ratio of the Aid flow (current US$) in Low income in 1999 to that in 2000?
Offer a terse response. 0.8. What is the ratio of the Aid flow (current US$) in Kazakhstan in 1999 to that in 2000?
Make the answer very short. 0.41. What is the ratio of the Aid flow (current US$) in Liberia in 1999 to that in 2000?
Offer a very short reply. 1.58. What is the ratio of the Aid flow (current US$) of East Asia (all income levels) in 1999 to that in 2001?
Your response must be concise. 0.6. What is the ratio of the Aid flow (current US$) in Low income in 1999 to that in 2001?
Your response must be concise. 0.53. What is the ratio of the Aid flow (current US$) in Kazakhstan in 1999 to that in 2001?
Offer a terse response. 0.06. What is the ratio of the Aid flow (current US$) in Liberia in 1999 to that in 2001?
Your response must be concise. 1.4. What is the ratio of the Aid flow (current US$) of East Asia (all income levels) in 1999 to that in 2002?
Keep it short and to the point. 0.62. What is the ratio of the Aid flow (current US$) in Low income in 1999 to that in 2002?
Your answer should be compact. 0.46. What is the ratio of the Aid flow (current US$) of Kazakhstan in 1999 to that in 2002?
Offer a terse response. 0.06. What is the ratio of the Aid flow (current US$) of Liberia in 1999 to that in 2002?
Keep it short and to the point. 1.1. What is the ratio of the Aid flow (current US$) of East Asia (all income levels) in 1999 to that in 2003?
Keep it short and to the point. 0.8. What is the ratio of the Aid flow (current US$) of Low income in 1999 to that in 2003?
Offer a terse response. 0.42. What is the ratio of the Aid flow (current US$) of Kazakhstan in 1999 to that in 2003?
Offer a very short reply. 0.05. What is the ratio of the Aid flow (current US$) of Liberia in 1999 to that in 2003?
Your answer should be compact. 0.35. What is the ratio of the Aid flow (current US$) of East Asia (all income levels) in 1999 to that in 2004?
Ensure brevity in your answer.  0.99. What is the ratio of the Aid flow (current US$) in Low income in 1999 to that in 2004?
Your answer should be compact. 0.42. What is the ratio of the Aid flow (current US$) in Kazakhstan in 1999 to that in 2004?
Your answer should be very brief. 0.04. What is the ratio of the Aid flow (current US$) in Liberia in 1999 to that in 2004?
Make the answer very short. 0.37. What is the ratio of the Aid flow (current US$) of East Asia (all income levels) in 1999 to that in 2005?
Your answer should be compact. 0.43. What is the ratio of the Aid flow (current US$) in Low income in 1999 to that in 2005?
Ensure brevity in your answer.  0.44. What is the ratio of the Aid flow (current US$) of Kazakhstan in 1999 to that in 2005?
Ensure brevity in your answer.  0.05. What is the ratio of the Aid flow (current US$) in Liberia in 1999 to that in 2005?
Offer a very short reply. 0.44. What is the ratio of the Aid flow (current US$) of East Asia (all income levels) in 1999 to that in 2006?
Keep it short and to the point. 0.68. What is the ratio of the Aid flow (current US$) in Low income in 1999 to that in 2006?
Give a very brief answer. 0.47. What is the ratio of the Aid flow (current US$) of Kazakhstan in 1999 to that in 2006?
Provide a short and direct response. 0.48. What is the ratio of the Aid flow (current US$) in Liberia in 1999 to that in 2006?
Offer a very short reply. 0.48. What is the ratio of the Aid flow (current US$) in East Asia (all income levels) in 2000 to that in 2001?
Your response must be concise. 0.93. What is the ratio of the Aid flow (current US$) of Low income in 2000 to that in 2001?
Provide a short and direct response. 0.67. What is the ratio of the Aid flow (current US$) of Kazakhstan in 2000 to that in 2001?
Your answer should be very brief. 0.13. What is the ratio of the Aid flow (current US$) of Liberia in 2000 to that in 2001?
Ensure brevity in your answer.  0.89. What is the ratio of the Aid flow (current US$) of East Asia (all income levels) in 2000 to that in 2002?
Offer a very short reply. 0.95. What is the ratio of the Aid flow (current US$) of Low income in 2000 to that in 2002?
Ensure brevity in your answer.  0.58. What is the ratio of the Aid flow (current US$) of Kazakhstan in 2000 to that in 2002?
Give a very brief answer. 0.14. What is the ratio of the Aid flow (current US$) of Liberia in 2000 to that in 2002?
Make the answer very short. 0.69. What is the ratio of the Aid flow (current US$) in East Asia (all income levels) in 2000 to that in 2003?
Make the answer very short. 1.24. What is the ratio of the Aid flow (current US$) of Low income in 2000 to that in 2003?
Ensure brevity in your answer.  0.52. What is the ratio of the Aid flow (current US$) of Kazakhstan in 2000 to that in 2003?
Your response must be concise. 0.12. What is the ratio of the Aid flow (current US$) in Liberia in 2000 to that in 2003?
Offer a terse response. 0.22. What is the ratio of the Aid flow (current US$) in East Asia (all income levels) in 2000 to that in 2004?
Give a very brief answer. 1.53. What is the ratio of the Aid flow (current US$) of Low income in 2000 to that in 2004?
Ensure brevity in your answer.  0.53. What is the ratio of the Aid flow (current US$) in Kazakhstan in 2000 to that in 2004?
Offer a very short reply. 0.09. What is the ratio of the Aid flow (current US$) of Liberia in 2000 to that in 2004?
Ensure brevity in your answer.  0.23. What is the ratio of the Aid flow (current US$) of East Asia (all income levels) in 2000 to that in 2005?
Make the answer very short. 0.67. What is the ratio of the Aid flow (current US$) in Low income in 2000 to that in 2005?
Keep it short and to the point. 0.55. What is the ratio of the Aid flow (current US$) in Kazakhstan in 2000 to that in 2005?
Offer a terse response. 0.12. What is the ratio of the Aid flow (current US$) of Liberia in 2000 to that in 2005?
Offer a very short reply. 0.28. What is the ratio of the Aid flow (current US$) in East Asia (all income levels) in 2000 to that in 2006?
Offer a very short reply. 1.04. What is the ratio of the Aid flow (current US$) in Low income in 2000 to that in 2006?
Provide a short and direct response. 0.59. What is the ratio of the Aid flow (current US$) in Kazakhstan in 2000 to that in 2006?
Offer a very short reply. 1.16. What is the ratio of the Aid flow (current US$) in Liberia in 2000 to that in 2006?
Offer a very short reply. 0.31. What is the ratio of the Aid flow (current US$) of East Asia (all income levels) in 2001 to that in 2002?
Make the answer very short. 1.03. What is the ratio of the Aid flow (current US$) in Low income in 2001 to that in 2002?
Your response must be concise. 0.86. What is the ratio of the Aid flow (current US$) of Kazakhstan in 2001 to that in 2002?
Provide a succinct answer. 1.07. What is the ratio of the Aid flow (current US$) in Liberia in 2001 to that in 2002?
Provide a short and direct response. 0.78. What is the ratio of the Aid flow (current US$) in East Asia (all income levels) in 2001 to that in 2003?
Your response must be concise. 1.33. What is the ratio of the Aid flow (current US$) in Low income in 2001 to that in 2003?
Ensure brevity in your answer.  0.78. What is the ratio of the Aid flow (current US$) in Kazakhstan in 2001 to that in 2003?
Make the answer very short. 0.86. What is the ratio of the Aid flow (current US$) in Liberia in 2001 to that in 2003?
Give a very brief answer. 0.25. What is the ratio of the Aid flow (current US$) in East Asia (all income levels) in 2001 to that in 2004?
Offer a terse response. 1.64. What is the ratio of the Aid flow (current US$) in Low income in 2001 to that in 2004?
Offer a very short reply. 0.79. What is the ratio of the Aid flow (current US$) of Kazakhstan in 2001 to that in 2004?
Give a very brief answer. 0.65. What is the ratio of the Aid flow (current US$) in Liberia in 2001 to that in 2004?
Ensure brevity in your answer.  0.26. What is the ratio of the Aid flow (current US$) of East Asia (all income levels) in 2001 to that in 2005?
Ensure brevity in your answer.  0.72. What is the ratio of the Aid flow (current US$) of Low income in 2001 to that in 2005?
Give a very brief answer. 0.83. What is the ratio of the Aid flow (current US$) in Kazakhstan in 2001 to that in 2005?
Provide a short and direct response. 0.91. What is the ratio of the Aid flow (current US$) of Liberia in 2001 to that in 2005?
Your response must be concise. 0.31. What is the ratio of the Aid flow (current US$) of East Asia (all income levels) in 2001 to that in 2006?
Make the answer very short. 1.12. What is the ratio of the Aid flow (current US$) of Low income in 2001 to that in 2006?
Provide a short and direct response. 0.88. What is the ratio of the Aid flow (current US$) of Liberia in 2001 to that in 2006?
Your response must be concise. 0.34. What is the ratio of the Aid flow (current US$) in East Asia (all income levels) in 2002 to that in 2003?
Your answer should be very brief. 1.3. What is the ratio of the Aid flow (current US$) in Low income in 2002 to that in 2003?
Make the answer very short. 0.91. What is the ratio of the Aid flow (current US$) of Kazakhstan in 2002 to that in 2003?
Your answer should be compact. 0.8. What is the ratio of the Aid flow (current US$) in Liberia in 2002 to that in 2003?
Your answer should be very brief. 0.32. What is the ratio of the Aid flow (current US$) in East Asia (all income levels) in 2002 to that in 2004?
Make the answer very short. 1.6. What is the ratio of the Aid flow (current US$) of Low income in 2002 to that in 2004?
Your answer should be very brief. 0.92. What is the ratio of the Aid flow (current US$) in Kazakhstan in 2002 to that in 2004?
Give a very brief answer. 0.61. What is the ratio of the Aid flow (current US$) in Liberia in 2002 to that in 2004?
Provide a succinct answer. 0.33. What is the ratio of the Aid flow (current US$) of East Asia (all income levels) in 2002 to that in 2005?
Ensure brevity in your answer.  0.7. What is the ratio of the Aid flow (current US$) in Low income in 2002 to that in 2005?
Make the answer very short. 0.96. What is the ratio of the Aid flow (current US$) in Kazakhstan in 2002 to that in 2005?
Your answer should be very brief. 0.85. What is the ratio of the Aid flow (current US$) in East Asia (all income levels) in 2002 to that in 2006?
Offer a terse response. 1.09. What is the ratio of the Aid flow (current US$) in Low income in 2002 to that in 2006?
Provide a succinct answer. 1.02. What is the ratio of the Aid flow (current US$) in Kazakhstan in 2002 to that in 2006?
Ensure brevity in your answer.  8.04. What is the ratio of the Aid flow (current US$) of Liberia in 2002 to that in 2006?
Provide a short and direct response. 0.44. What is the ratio of the Aid flow (current US$) of East Asia (all income levels) in 2003 to that in 2004?
Provide a short and direct response. 1.23. What is the ratio of the Aid flow (current US$) in Low income in 2003 to that in 2004?
Your answer should be compact. 1.02. What is the ratio of the Aid flow (current US$) in Kazakhstan in 2003 to that in 2004?
Make the answer very short. 0.76. What is the ratio of the Aid flow (current US$) in Liberia in 2003 to that in 2004?
Your answer should be very brief. 1.04. What is the ratio of the Aid flow (current US$) in East Asia (all income levels) in 2003 to that in 2005?
Make the answer very short. 0.54. What is the ratio of the Aid flow (current US$) of Low income in 2003 to that in 2005?
Offer a terse response. 1.06. What is the ratio of the Aid flow (current US$) in Kazakhstan in 2003 to that in 2005?
Ensure brevity in your answer.  1.06. What is the ratio of the Aid flow (current US$) in Liberia in 2003 to that in 2005?
Offer a very short reply. 1.25. What is the ratio of the Aid flow (current US$) in East Asia (all income levels) in 2003 to that in 2006?
Give a very brief answer. 0.84. What is the ratio of the Aid flow (current US$) in Low income in 2003 to that in 2006?
Make the answer very short. 1.13. What is the ratio of the Aid flow (current US$) of Kazakhstan in 2003 to that in 2006?
Offer a very short reply. 10.04. What is the ratio of the Aid flow (current US$) in Liberia in 2003 to that in 2006?
Ensure brevity in your answer.  1.38. What is the ratio of the Aid flow (current US$) of East Asia (all income levels) in 2004 to that in 2005?
Ensure brevity in your answer.  0.44. What is the ratio of the Aid flow (current US$) of Low income in 2004 to that in 2005?
Offer a terse response. 1.04. What is the ratio of the Aid flow (current US$) of Kazakhstan in 2004 to that in 2005?
Your answer should be very brief. 1.41. What is the ratio of the Aid flow (current US$) in Liberia in 2004 to that in 2005?
Provide a short and direct response. 1.2. What is the ratio of the Aid flow (current US$) of East Asia (all income levels) in 2004 to that in 2006?
Your answer should be very brief. 0.68. What is the ratio of the Aid flow (current US$) of Low income in 2004 to that in 2006?
Keep it short and to the point. 1.11. What is the ratio of the Aid flow (current US$) of Kazakhstan in 2004 to that in 2006?
Offer a very short reply. 13.28. What is the ratio of the Aid flow (current US$) in Liberia in 2004 to that in 2006?
Offer a terse response. 1.32. What is the ratio of the Aid flow (current US$) of East Asia (all income levels) in 2005 to that in 2006?
Your response must be concise. 1.56. What is the ratio of the Aid flow (current US$) in Low income in 2005 to that in 2006?
Provide a succinct answer. 1.06. What is the ratio of the Aid flow (current US$) in Kazakhstan in 2005 to that in 2006?
Your answer should be very brief. 9.44. What is the ratio of the Aid flow (current US$) of Liberia in 2005 to that in 2006?
Make the answer very short. 1.1. What is the difference between the highest and the second highest Aid flow (current US$) of East Asia (all income levels)?
Keep it short and to the point. 9.19e+07. What is the difference between the highest and the second highest Aid flow (current US$) of Low income?
Provide a short and direct response. 1.31e+07. What is the difference between the highest and the second highest Aid flow (current US$) of Kazakhstan?
Provide a succinct answer. 8.10e+05. What is the difference between the highest and the second highest Aid flow (current US$) of Liberia?
Provide a short and direct response. 3.60e+05. What is the difference between the highest and the lowest Aid flow (current US$) in East Asia (all income levels)?
Ensure brevity in your answer.  1.84e+08. What is the difference between the highest and the lowest Aid flow (current US$) of Low income?
Provide a short and direct response. 5.04e+08. What is the difference between the highest and the lowest Aid flow (current US$) of Kazakhstan?
Provide a succinct answer. 3.20e+06. What is the difference between the highest and the lowest Aid flow (current US$) in Liberia?
Your response must be concise. 6.98e+06. 